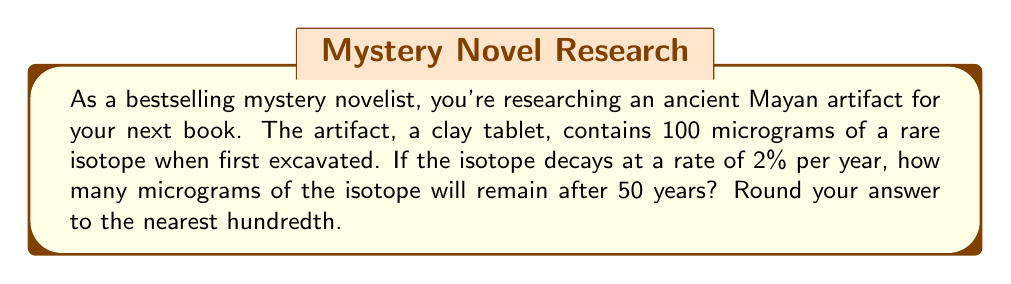Give your solution to this math problem. Let's approach this step-by-step using an exponential decay function:

1) The general form of an exponential decay function is:
   $A(t) = A_0 \cdot (1-r)^t$
   Where:
   $A(t)$ is the amount remaining after time $t$
   $A_0$ is the initial amount
   $r$ is the decay rate (as a decimal)
   $t$ is the time

2) In this problem:
   $A_0 = 100$ micrograms
   $r = 0.02$ (2% expressed as a decimal)
   $t = 50$ years

3) Substituting these values into our equation:
   $A(50) = 100 \cdot (1-0.02)^{50}$

4) Simplify inside the parentheses:
   $A(50) = 100 \cdot (0.98)^{50}$

5) Use a calculator to evaluate $(0.98)^{50}$:
   $(0.98)^{50} \approx 0.3641$

6) Multiply by 100:
   $A(50) = 100 \cdot 0.3641 = 36.41$ micrograms

7) Rounding to the nearest hundredth:
   $A(50) \approx 36.41$ micrograms

Therefore, after 50 years, approximately 36.41 micrograms of the isotope will remain.
Answer: 36.41 micrograms 